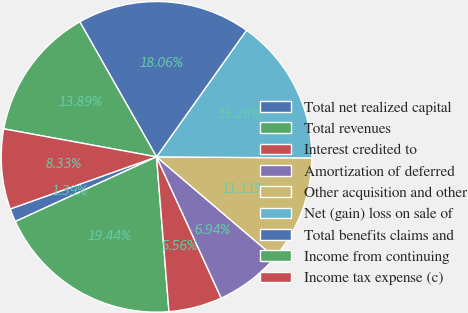<chart> <loc_0><loc_0><loc_500><loc_500><pie_chart><fcel>Total net realized capital<fcel>Total revenues<fcel>Interest credited to<fcel>Amortization of deferred<fcel>Other acquisition and other<fcel>Net (gain) loss on sale of<fcel>Total benefits claims and<fcel>Income from continuing<fcel>Income tax expense (c)<nl><fcel>1.39%<fcel>19.44%<fcel>5.56%<fcel>6.94%<fcel>11.11%<fcel>15.28%<fcel>18.06%<fcel>13.89%<fcel>8.33%<nl></chart> 